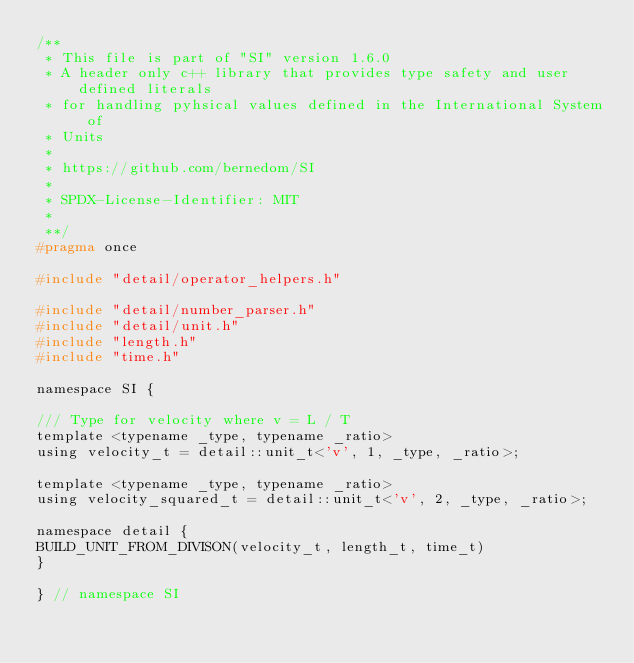Convert code to text. <code><loc_0><loc_0><loc_500><loc_500><_C_>/**
 * This file is part of "SI" version 1.6.0
 * A header only c++ library that provides type safety and user defined literals
 * for handling pyhsical values defined in the International System of
 * Units
 *
 * https://github.com/bernedom/SI
 *
 * SPDX-License-Identifier: MIT
 *
 **/
#pragma once

#include "detail/operator_helpers.h"

#include "detail/number_parser.h"
#include "detail/unit.h"
#include "length.h"
#include "time.h"

namespace SI {

/// Type for velocity where v = L / T
template <typename _type, typename _ratio>
using velocity_t = detail::unit_t<'v', 1, _type, _ratio>;

template <typename _type, typename _ratio>
using velocity_squared_t = detail::unit_t<'v', 2, _type, _ratio>;

namespace detail {
BUILD_UNIT_FROM_DIVISON(velocity_t, length_t, time_t)
}

} // namespace SI</code> 